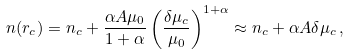<formula> <loc_0><loc_0><loc_500><loc_500>n ( r _ { c } ) = n _ { c } + \frac { \alpha A \mu _ { 0 } } { 1 + \alpha } \left ( \frac { \delta \mu _ { c } } { \mu _ { 0 } } \right ) ^ { 1 + \alpha } \approx n _ { c } + \alpha A \delta \mu _ { c } \, ,</formula> 